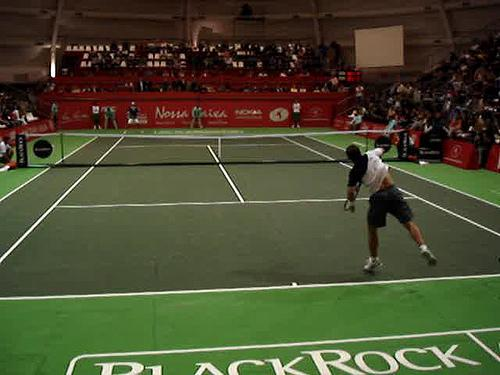What type of tennis swing is the main on the bottom of the court in the middle of? serve 